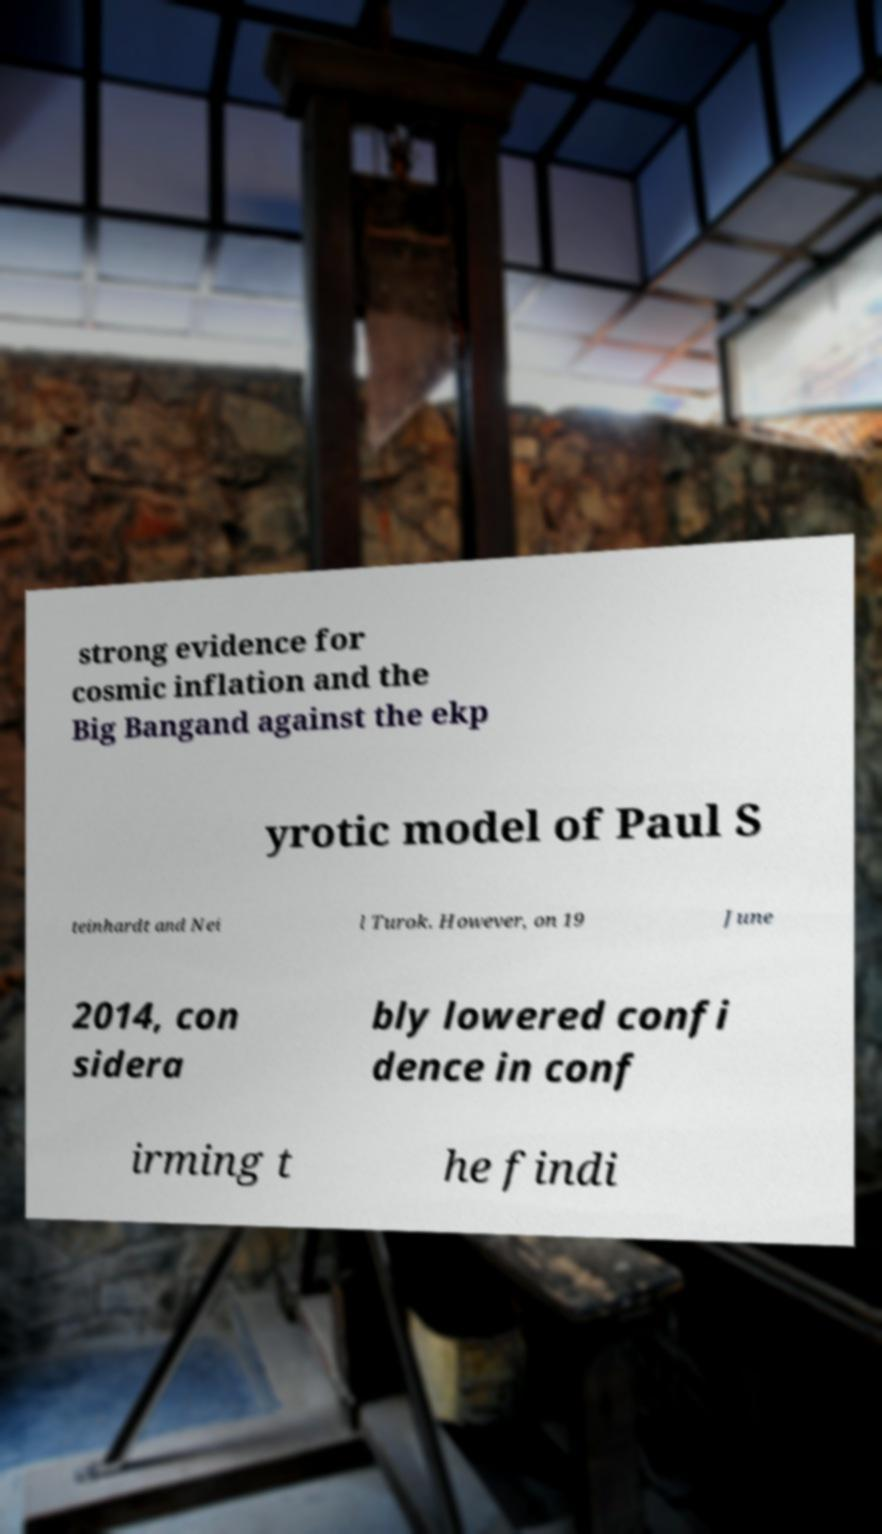Could you extract and type out the text from this image? strong evidence for cosmic inflation and the Big Bangand against the ekp yrotic model of Paul S teinhardt and Nei l Turok. However, on 19 June 2014, con sidera bly lowered confi dence in conf irming t he findi 